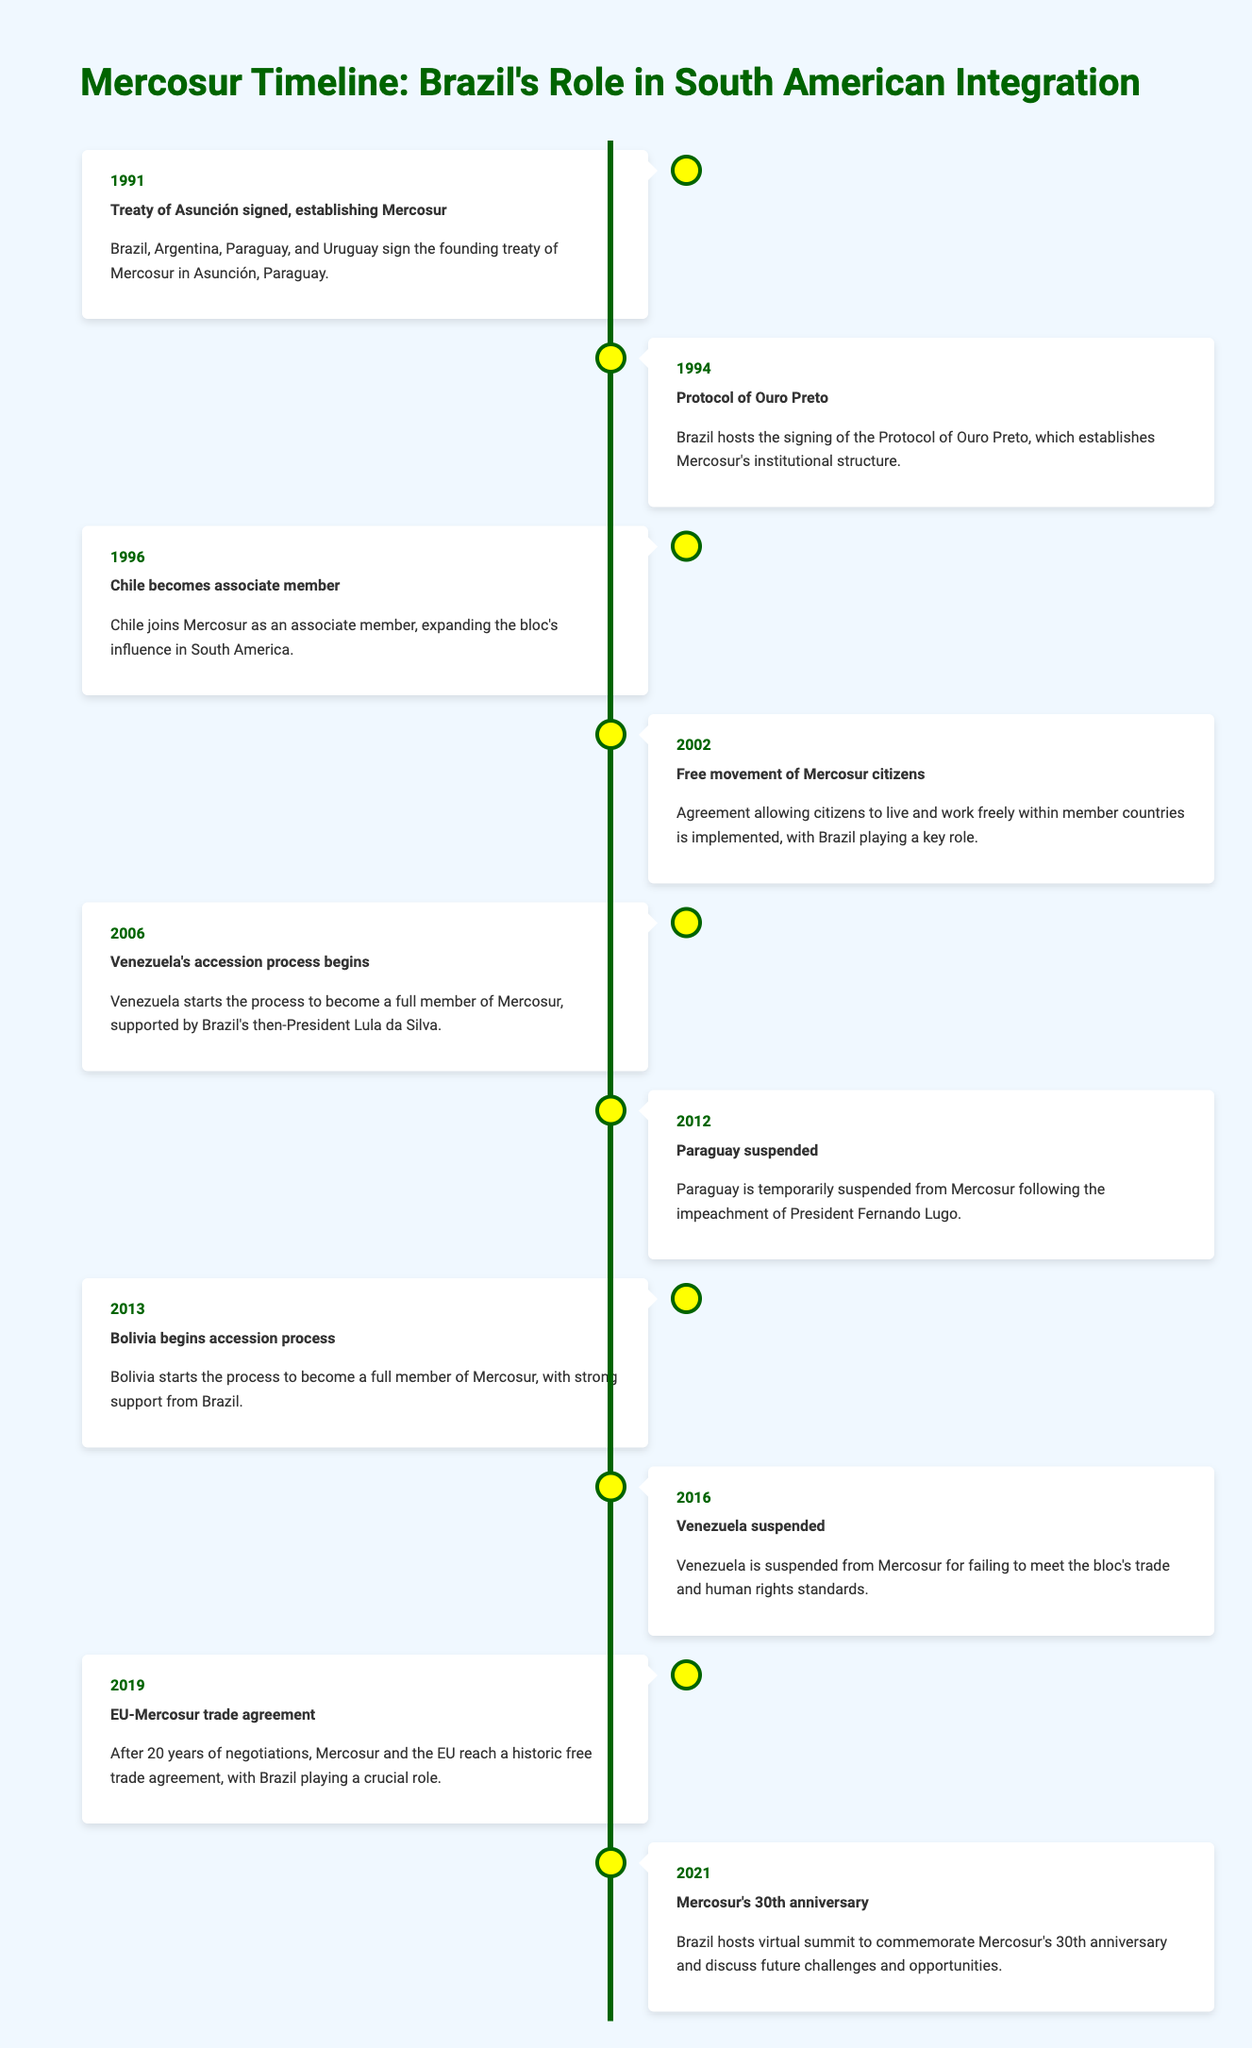What year was the Treaty of Asunción signed? The Treaty of Asunción was signed in 1991, as indicated in the timeline.
Answer: 1991 Which event in the timeline involved Venezuela? There are two events related to Venezuela: one in 2006 when its accession process began, and another in 2016 when it was suspended from Mercosur.
Answer: Yes, two events How many years passed between the signing of the Protocol of Ouro Preto and the EU-Mercosur trade agreement? The Protocol of Ouro Preto was signed in 1994 and the EU-Mercosur trade agreement was reached in 2019. The difference is 2019 - 1994 = 25 years.
Answer: 25 years Did Bolivia have support from Brazil during its accession process to Mercosur? Yes, the timeline indicates that Bolivia's accession process began in 2013 with strong support from Brazil.
Answer: Yes What is the total number of years from the founding of Mercosur to its 30th anniversary? Mercosur was founded in 1991, and its 30th anniversary was celebrated in 2021. The total years calculated is 2021 - 1991 = 30 years.
Answer: 30 years What significant event relating to Paraguay occurred in 2012? In 2012, Paraguay was temporarily suspended from Mercosur following the impeachment of President Fernando Lugo.
Answer: Paraguay was suspended What events occurred in 2013 and what was their relationship? In 2013, Bolivia began its accession process to become a member of Mercosur, which shows an expansion effort of the bloc during that year.
Answer: Bolivia began accession process How many events were there regarding suspensions in the timeline? There are two suspension events mentioned: Paraguay's suspension in 2012 and Venezuela's suspension in 2016.
Answer: Two events What does the timeline suggest about Brazil's role in Mercosur's expansion? Brazil has consistently played a key role in various expansion efforts, including supporting Venezuela's and Bolivia's accession processes, as well as hosting significant events.
Answer: Brazil had a key role in expansion 